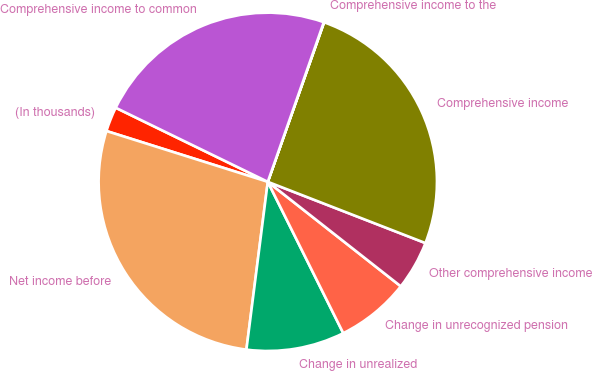Convert chart. <chart><loc_0><loc_0><loc_500><loc_500><pie_chart><fcel>(In thousands)<fcel>Net income before<fcel>Change in unrealized<fcel>Change in unrecognized pension<fcel>Other comprehensive income<fcel>Comprehensive income<fcel>Comprehensive income to the<fcel>Comprehensive income to common<nl><fcel>2.36%<fcel>27.84%<fcel>9.38%<fcel>7.04%<fcel>4.7%<fcel>25.5%<fcel>0.03%<fcel>23.16%<nl></chart> 